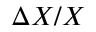Convert formula to latex. <formula><loc_0><loc_0><loc_500><loc_500>\Delta X / X</formula> 